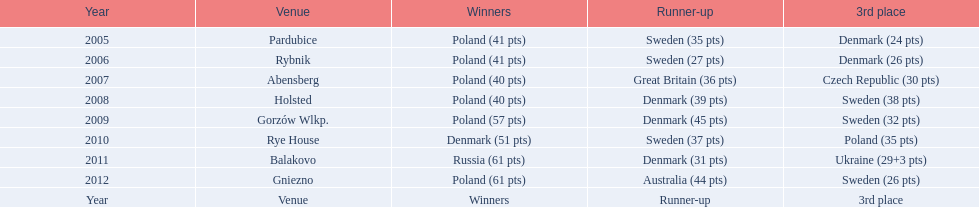In what years did denmark place in the top 3 in the team speedway junior world championship? 2005, 2006, 2008, 2009, 2010, 2011. Parse the table in full. {'header': ['Year', 'Venue', 'Winners', 'Runner-up', '3rd place'], 'rows': [['2005', 'Pardubice', 'Poland (41 pts)', 'Sweden (35 pts)', 'Denmark (24 pts)'], ['2006', 'Rybnik', 'Poland (41 pts)', 'Sweden (27 pts)', 'Denmark (26 pts)'], ['2007', 'Abensberg', 'Poland (40 pts)', 'Great Britain (36 pts)', 'Czech Republic (30 pts)'], ['2008', 'Holsted', 'Poland (40 pts)', 'Denmark (39 pts)', 'Sweden (38 pts)'], ['2009', 'Gorzów Wlkp.', 'Poland (57 pts)', 'Denmark (45 pts)', 'Sweden (32 pts)'], ['2010', 'Rye House', 'Denmark (51 pts)', 'Sweden (37 pts)', 'Poland (35 pts)'], ['2011', 'Balakovo', 'Russia (61 pts)', 'Denmark (31 pts)', 'Ukraine (29+3 pts)'], ['2012', 'Gniezno', 'Poland (61 pts)', 'Australia (44 pts)', 'Sweden (26 pts)'], ['Year', 'Venue', 'Winners', 'Runner-up', '3rd place']]} What in what year did denmark come withing 2 points of placing higher in the standings? 2006. What place did denmark receive the year they missed higher ranking by only 2 points? 3rd place. 